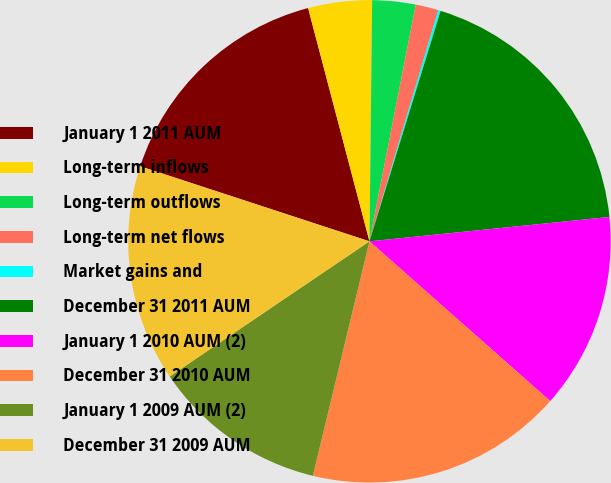<chart> <loc_0><loc_0><loc_500><loc_500><pie_chart><fcel>January 1 2011 AUM<fcel>Long-term inflows<fcel>Long-term outflows<fcel>Long-term net flows<fcel>Market gains and<fcel>December 31 2011 AUM<fcel>January 1 2010 AUM (2)<fcel>December 31 2010 AUM<fcel>January 1 2009 AUM (2)<fcel>December 31 2009 AUM<nl><fcel>15.87%<fcel>4.27%<fcel>2.9%<fcel>1.53%<fcel>0.16%<fcel>18.62%<fcel>13.13%<fcel>17.25%<fcel>11.76%<fcel>14.5%<nl></chart> 